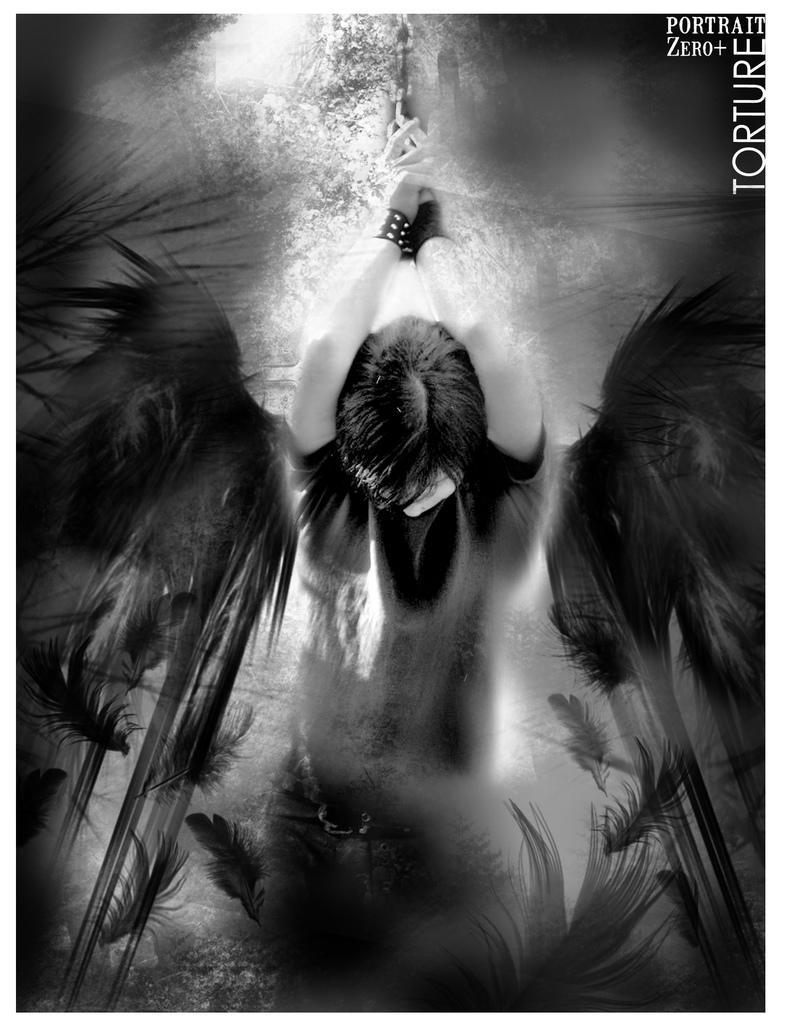Can you describe this image briefly? In this image we can see an edited picture of a person and trees, also we can see the text on the image. 